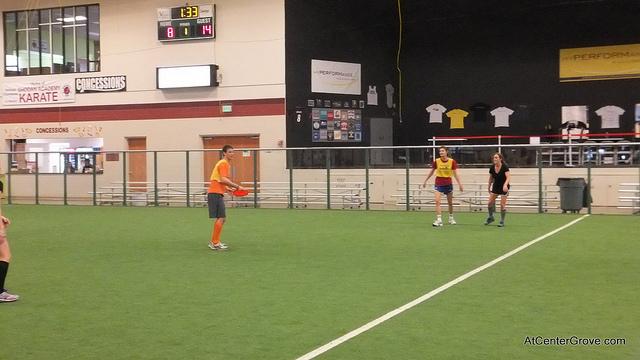How many shirts hanging?
Keep it brief. 4. What game is being played?
Keep it brief. Frisbee. Is this outdoors?
Keep it brief. No. What ballpark are they playing in?
Be succinct. Soccer field. Where are the people playing?
Concise answer only. Frisbee. What game is this man playing?
Keep it brief. Frisbee. 